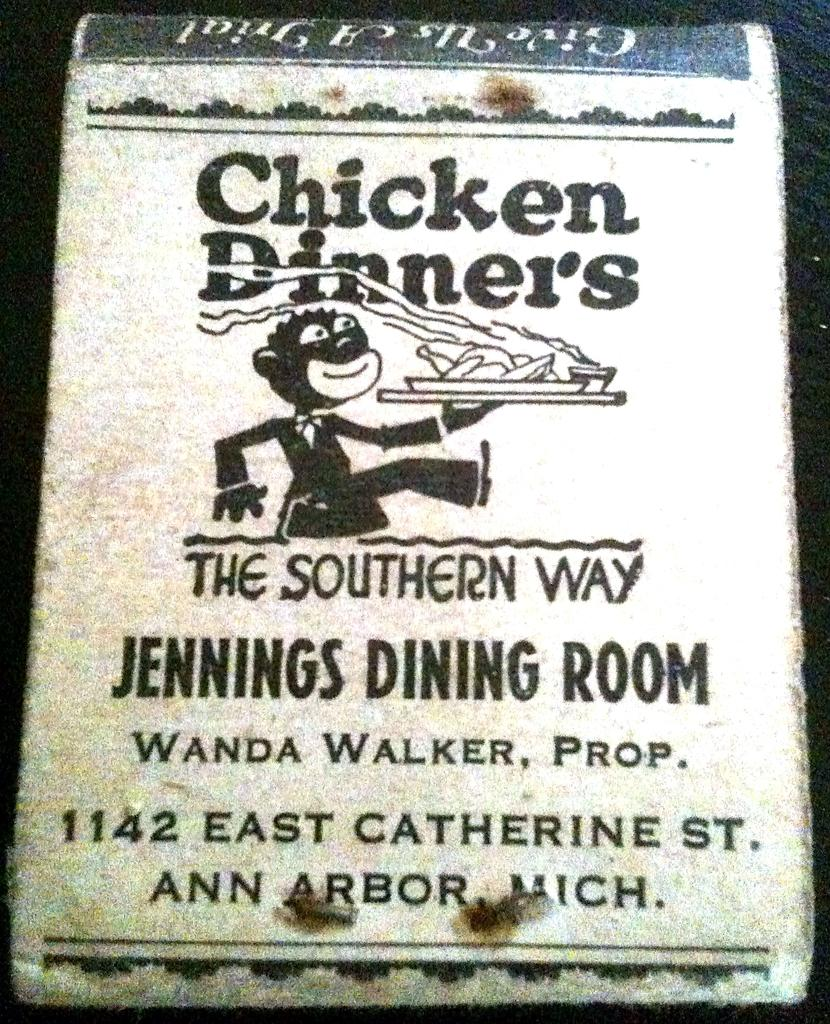<image>
Present a compact description of the photo's key features. Jennings Dining Room is located on East Catherine Street. 